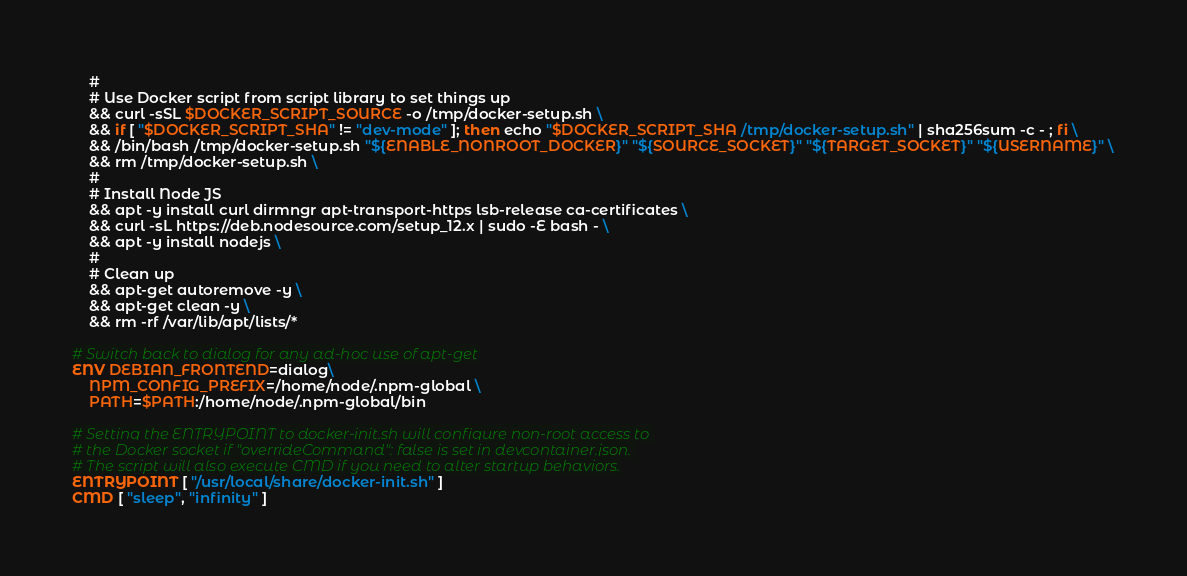Convert code to text. <code><loc_0><loc_0><loc_500><loc_500><_Dockerfile_>    #
    # Use Docker script from script library to set things up
    && curl -sSL $DOCKER_SCRIPT_SOURCE -o /tmp/docker-setup.sh \
    && if [ "$DOCKER_SCRIPT_SHA" != "dev-mode" ]; then echo "$DOCKER_SCRIPT_SHA /tmp/docker-setup.sh" | sha256sum -c - ; fi \
    && /bin/bash /tmp/docker-setup.sh "${ENABLE_NONROOT_DOCKER}" "${SOURCE_SOCKET}" "${TARGET_SOCKET}" "${USERNAME}" \
    && rm /tmp/docker-setup.sh \
    #
    # Install Node JS
    && apt -y install curl dirmngr apt-transport-https lsb-release ca-certificates \
    && curl -sL https://deb.nodesource.com/setup_12.x | sudo -E bash - \
    && apt -y install nodejs \
    #
    # Clean up
    && apt-get autoremove -y \
    && apt-get clean -y \
    && rm -rf /var/lib/apt/lists/*

# Switch back to dialog for any ad-hoc use of apt-get
ENV DEBIAN_FRONTEND=dialog\
    NPM_CONFIG_PREFIX=/home/node/.npm-global \
    PATH=$PATH:/home/node/.npm-global/bin

# Setting the ENTRYPOINT to docker-init.sh will configure non-root access to 
# the Docker socket if "overrideCommand": false is set in devcontainer.json. 
# The script will also execute CMD if you need to alter startup behaviors.
ENTRYPOINT [ "/usr/local/share/docker-init.sh" ]
CMD [ "sleep", "infinity" ]</code> 